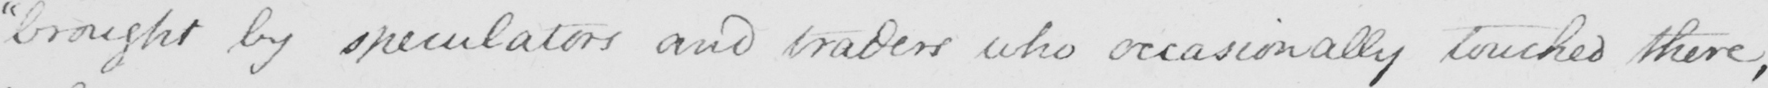Transcribe the text shown in this historical manuscript line. " brought by speculators and traders who occasionally touched there , 